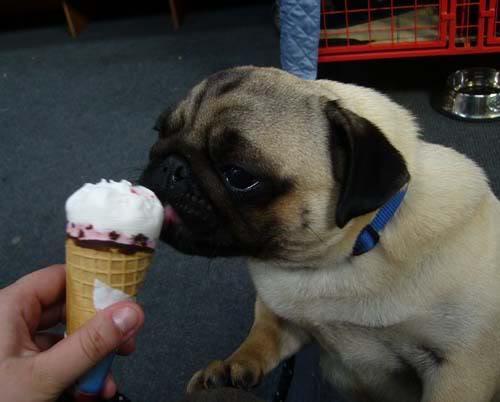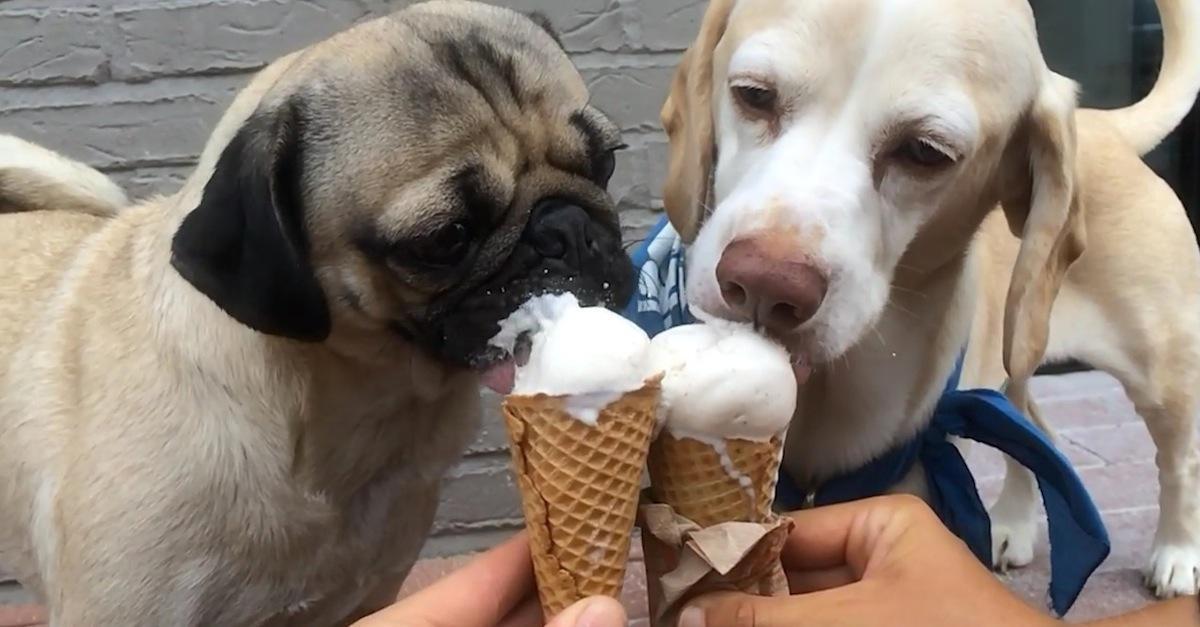The first image is the image on the left, the second image is the image on the right. For the images shown, is this caption "There is a dog that is not eating anything." true? Answer yes or no. No. The first image is the image on the left, the second image is the image on the right. For the images shown, is this caption "At least 2 dogs are being fed ice cream in a waffle cone that a person is holding." true? Answer yes or no. Yes. 